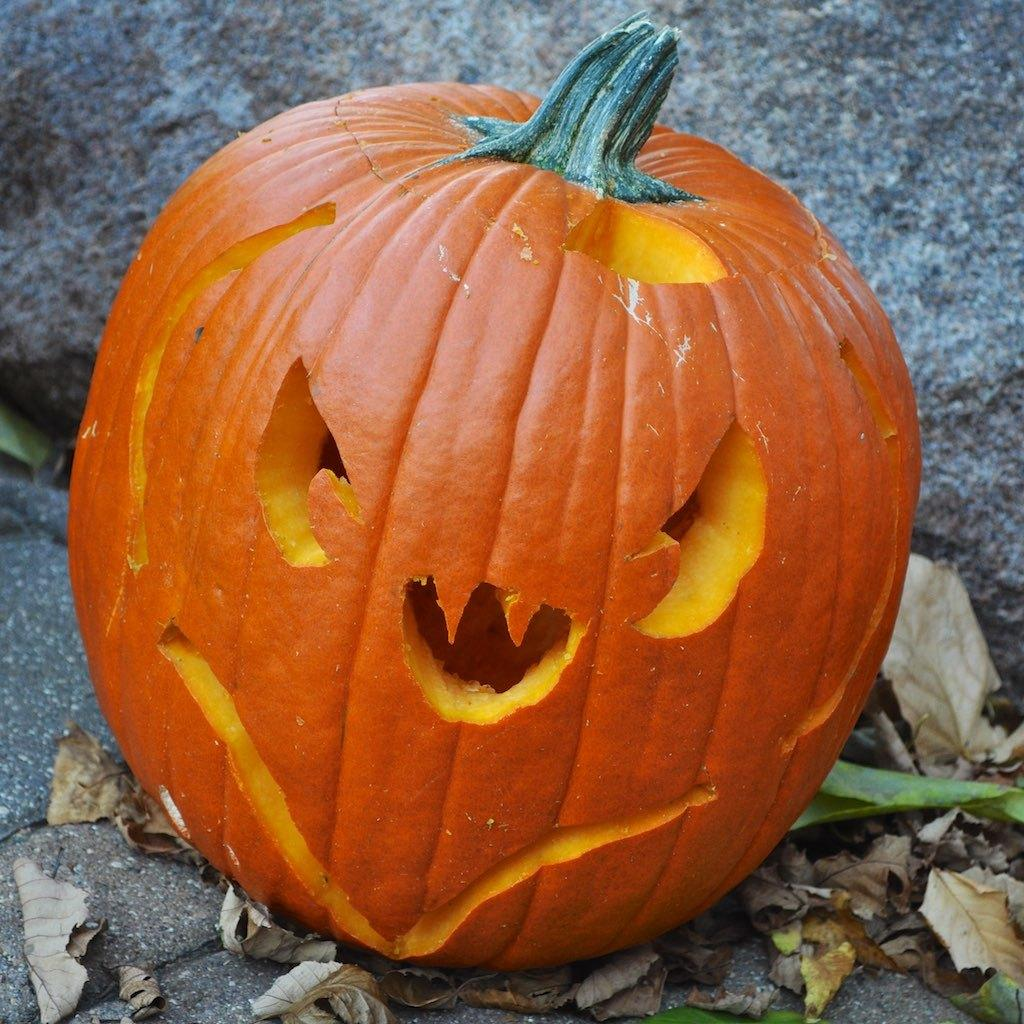What color is the pumpkin in the image? The pumpkin in the image is orange-colored. What can be found on the ground around the pumpkin? Leaves are present on the ground around the pumpkin. What type of pot is the pumpkin sitting on in the image? There is no pot present in the image; the pumpkin is on the ground among the leaves. 